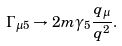<formula> <loc_0><loc_0><loc_500><loc_500>\Gamma _ { \mu 5 } \rightarrow 2 m \gamma _ { 5 } \frac { q _ { \mu } } { q ^ { 2 } } .</formula> 